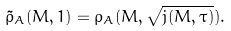Convert formula to latex. <formula><loc_0><loc_0><loc_500><loc_500>\tilde { \rho } _ { A } ( M , 1 ) = \rho _ { A } ( M , \sqrt { j ( M , \tau ) } ) .</formula> 